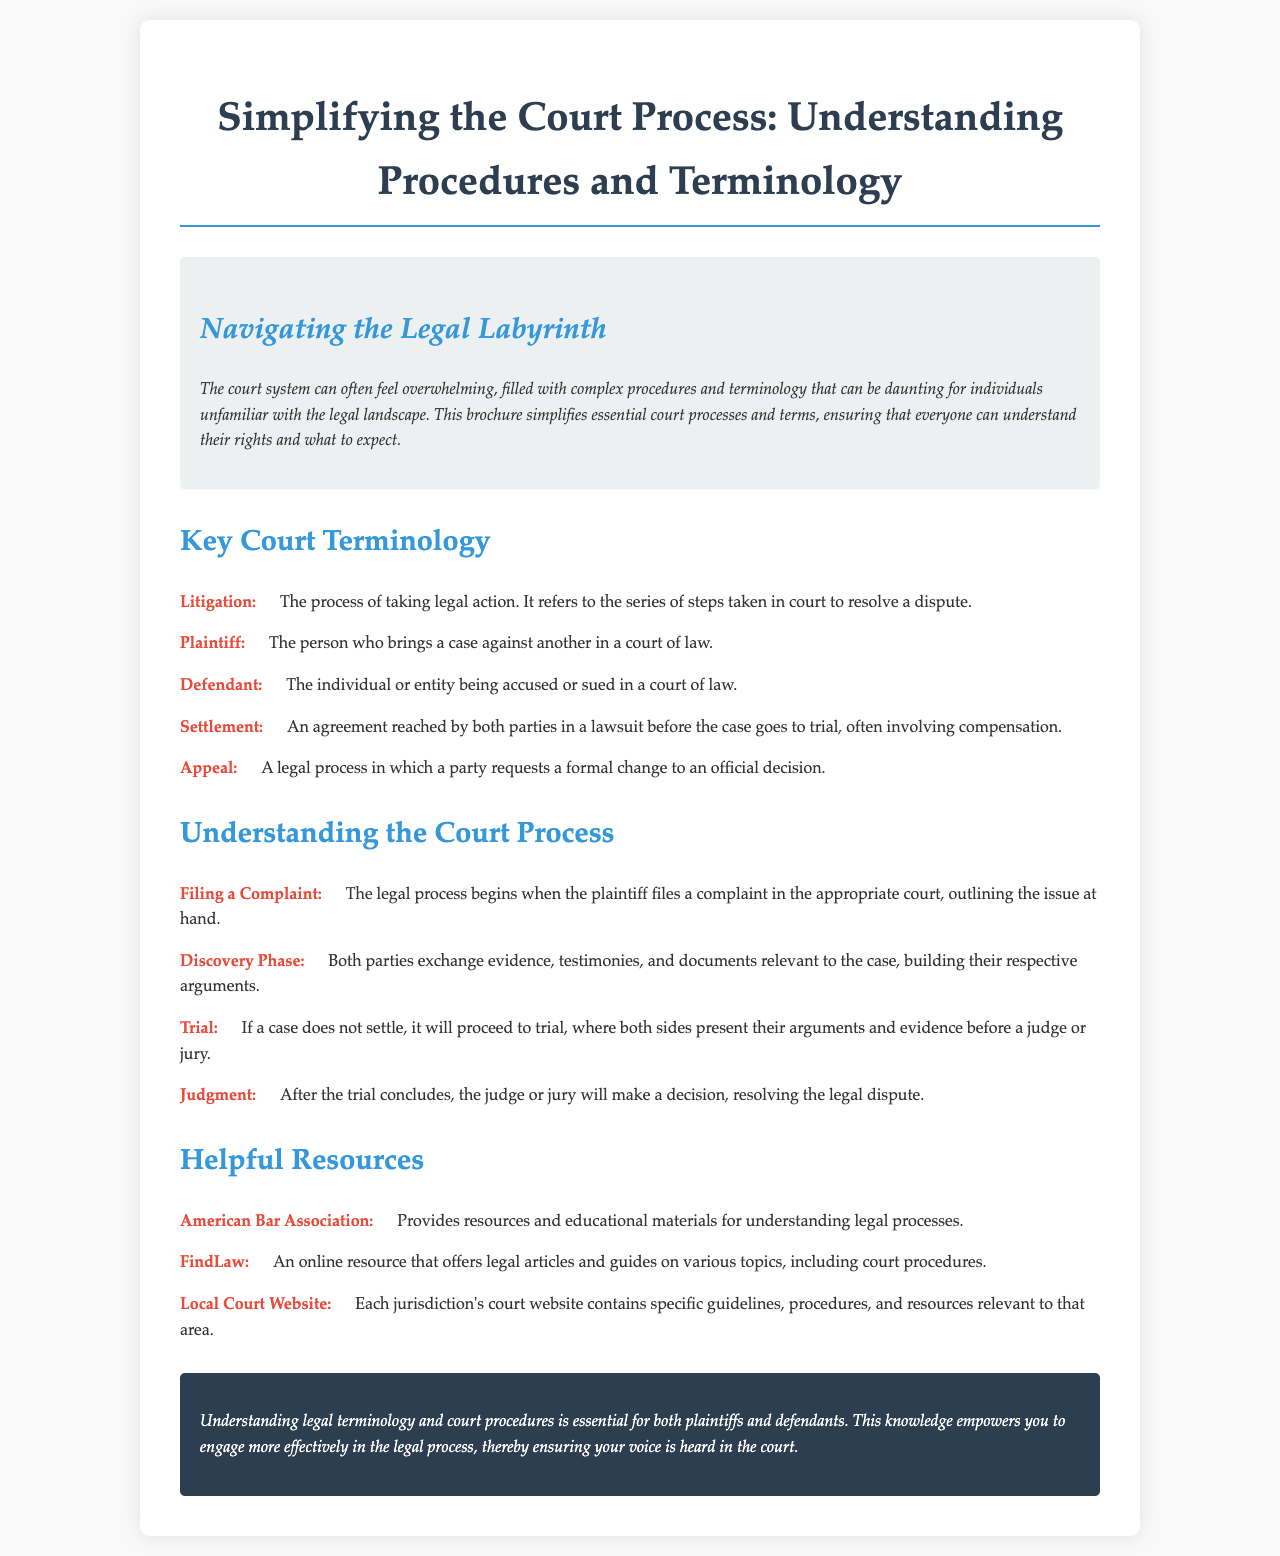What is the purpose of the brochure? The brochure simplifies essential court processes and terms, ensuring that everyone can understand their rights and what to expect.
Answer: Simplifies essential court processes and terms Who is the plaintiff? The plaintiff is defined as the person who brings a case against another in a court of law.
Answer: The person who brings a case against another What is the first step in the court process? The first step is when the plaintiff files a complaint in the appropriate court, outlining the issue at hand.
Answer: Filing a Complaint What organization provides resources for understanding legal processes? The American Bar Association is mentioned as providing resources and educational materials for understanding legal processes.
Answer: American Bar Association How many key court terms are explained in the brochure? There are five key court terms defined in the document.
Answer: Five What is a settlement? A settlement is described as an agreement reached by both parties in a lawsuit before the case goes to trial, often involving compensation.
Answer: An agreement reached before trial What does an appeal involve? An appeal is a legal process in which a party requests a formal change to an official decision.
Answer: A formal change to an official decision What happens after the trial concludes? After the trial concludes, the judge or jury will make a decision, resolving the legal dispute.
Answer: The judge or jury makes a decision Which website is noted for offering legal articles? FindLaw is mentioned as an online resource that offers legal articles and guides on various topics, including court procedures.
Answer: FindLaw 